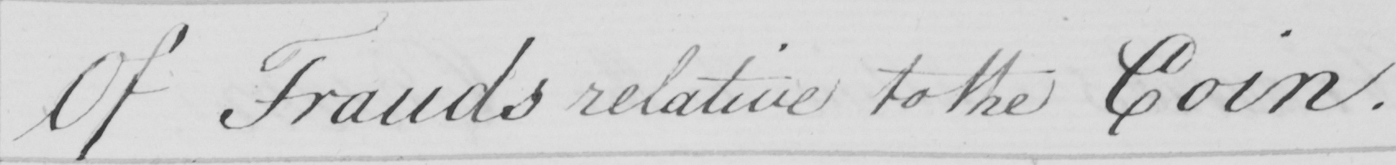What text is written in this handwritten line? Of Frauds relative to the Coin . 